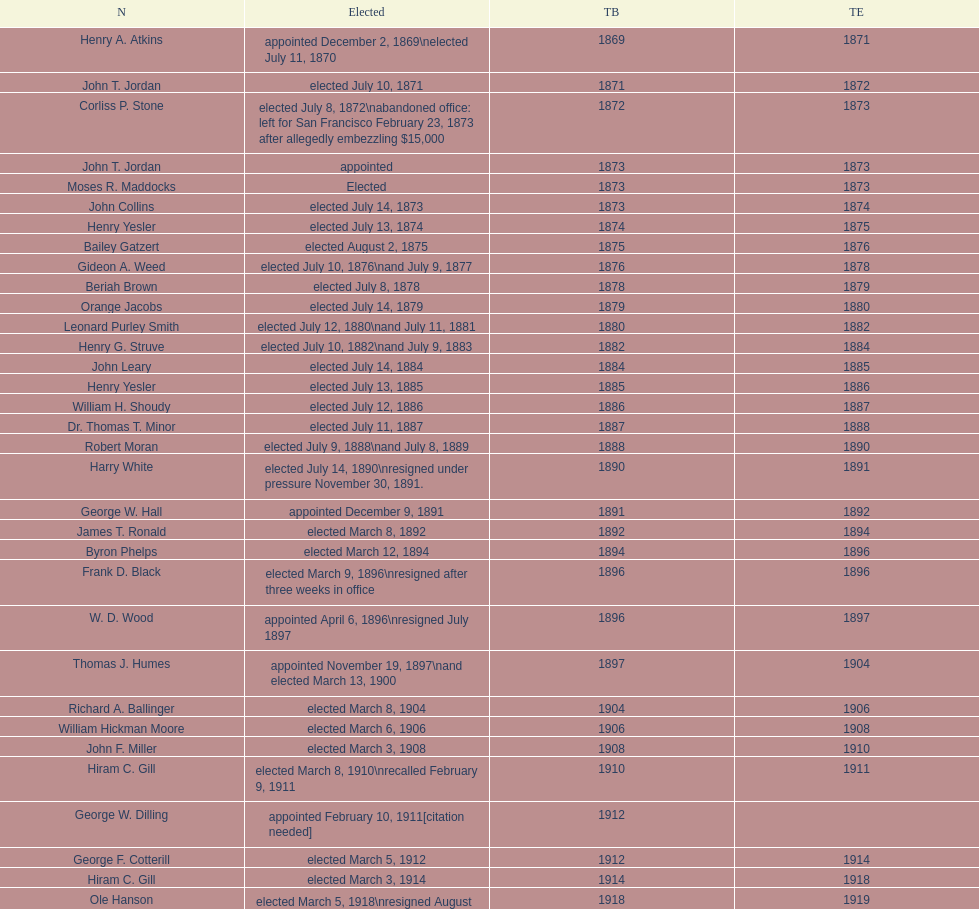Write the full table. {'header': ['N', 'Elected', 'TB', 'TE'], 'rows': [['Henry A. Atkins', 'appointed December 2, 1869\\nelected July 11, 1870', '1869', '1871'], ['John T. Jordan', 'elected July 10, 1871', '1871', '1872'], ['Corliss P. Stone', 'elected July 8, 1872\\nabandoned office: left for San Francisco February 23, 1873 after allegedly embezzling $15,000', '1872', '1873'], ['John T. Jordan', 'appointed', '1873', '1873'], ['Moses R. Maddocks', 'Elected', '1873', '1873'], ['John Collins', 'elected July 14, 1873', '1873', '1874'], ['Henry Yesler', 'elected July 13, 1874', '1874', '1875'], ['Bailey Gatzert', 'elected August 2, 1875', '1875', '1876'], ['Gideon A. Weed', 'elected July 10, 1876\\nand July 9, 1877', '1876', '1878'], ['Beriah Brown', 'elected July 8, 1878', '1878', '1879'], ['Orange Jacobs', 'elected July 14, 1879', '1879', '1880'], ['Leonard Purley Smith', 'elected July 12, 1880\\nand July 11, 1881', '1880', '1882'], ['Henry G. Struve', 'elected July 10, 1882\\nand July 9, 1883', '1882', '1884'], ['John Leary', 'elected July 14, 1884', '1884', '1885'], ['Henry Yesler', 'elected July 13, 1885', '1885', '1886'], ['William H. Shoudy', 'elected July 12, 1886', '1886', '1887'], ['Dr. Thomas T. Minor', 'elected July 11, 1887', '1887', '1888'], ['Robert Moran', 'elected July 9, 1888\\nand July 8, 1889', '1888', '1890'], ['Harry White', 'elected July 14, 1890\\nresigned under pressure November 30, 1891.', '1890', '1891'], ['George W. Hall', 'appointed December 9, 1891', '1891', '1892'], ['James T. Ronald', 'elected March 8, 1892', '1892', '1894'], ['Byron Phelps', 'elected March 12, 1894', '1894', '1896'], ['Frank D. Black', 'elected March 9, 1896\\nresigned after three weeks in office', '1896', '1896'], ['W. D. Wood', 'appointed April 6, 1896\\nresigned July 1897', '1896', '1897'], ['Thomas J. Humes', 'appointed November 19, 1897\\nand elected March 13, 1900', '1897', '1904'], ['Richard A. Ballinger', 'elected March 8, 1904', '1904', '1906'], ['William Hickman Moore', 'elected March 6, 1906', '1906', '1908'], ['John F. Miller', 'elected March 3, 1908', '1908', '1910'], ['Hiram C. Gill', 'elected March 8, 1910\\nrecalled February 9, 1911', '1910', '1911'], ['George W. Dilling', 'appointed February 10, 1911[citation needed]', '1912', ''], ['George F. Cotterill', 'elected March 5, 1912', '1912', '1914'], ['Hiram C. Gill', 'elected March 3, 1914', '1914', '1918'], ['Ole Hanson', 'elected March 5, 1918\\nresigned August 28, 1919 after several months out of town', '1918', '1919'], ['C. B. Fitzgerald', 'appointed August 28, 1919', '1919', '1920'], ['Hugh M. Caldwell', 'elected March 2, 1920', '1920', '1922'], ['Edwin J. Brown', 'elected May 2, 1922\\nand March 4, 1924', '1922', '1926'], ['Bertha Knight Landes', 'elected March 9, 1926', '1926', '1928'], ['Frank E. Edwards', 'elected March 6, 1928\\nand March 4, 1930\\nrecalled July 13, 1931', '1928', '1931'], ['Robert H. Harlin', 'appointed July 14, 1931', '1931', '1932'], ['John F. Dore', 'elected March 8, 1932', '1932', '1934'], ['Charles L. Smith', 'elected March 6, 1934', '1934', '1936'], ['John F. Dore', 'elected March 3, 1936\\nbecame gravely ill and was relieved of office April 13, 1938, already a lame duck after the 1938 election. He died five days later.', '1936', '1938'], ['Arthur B. Langlie', "elected March 8, 1938\\nappointed to take office early, April 27, 1938, after Dore's death.\\nelected March 5, 1940\\nresigned January 11, 1941, to become Governor of Washington", '1938', '1941'], ['John E. Carroll', 'appointed January 27, 1941', '1941', '1941'], ['Earl Millikin', 'elected March 4, 1941', '1941', '1942'], ['William F. Devin', 'elected March 3, 1942, March 7, 1944, March 5, 1946, and March 2, 1948', '1942', '1952'], ['Allan Pomeroy', 'elected March 4, 1952', '1952', '1956'], ['Gordon S. Clinton', 'elected March 6, 1956\\nand March 8, 1960', '1956', '1964'], ["James d'Orma Braman", 'elected March 10, 1964\\nresigned March 23, 1969, to accept an appointment as an Assistant Secretary in the Department of Transportation in the Nixon administration.', '1964', '1969'], ['Floyd C. Miller', 'appointed March 23, 1969', '1969', '1969'], ['Wesley C. Uhlman', 'elected November 4, 1969\\nand November 6, 1973\\nsurvived recall attempt on July 1, 1975', 'December 1, 1969', 'January 1, 1978'], ['Charles Royer', 'elected November 8, 1977, November 3, 1981, and November 5, 1985', 'January 1, 1978', 'January 1, 1990'], ['Norman B. Rice', 'elected November 7, 1989', 'January 1, 1990', 'January 1, 1998'], ['Paul Schell', 'elected November 4, 1997', 'January 1, 1998', 'January 1, 2002'], ['Gregory J. Nickels', 'elected November 6, 2001\\nand November 8, 2005', 'January 1, 2002', 'January 1, 2010'], ['Michael McGinn', 'elected November 3, 2009', 'January 1, 2010', 'January 1, 2014'], ['Ed Murray', 'elected November 5, 2013', 'January 1, 2014', 'present']]} Who started their period in 1890? Harry White. 